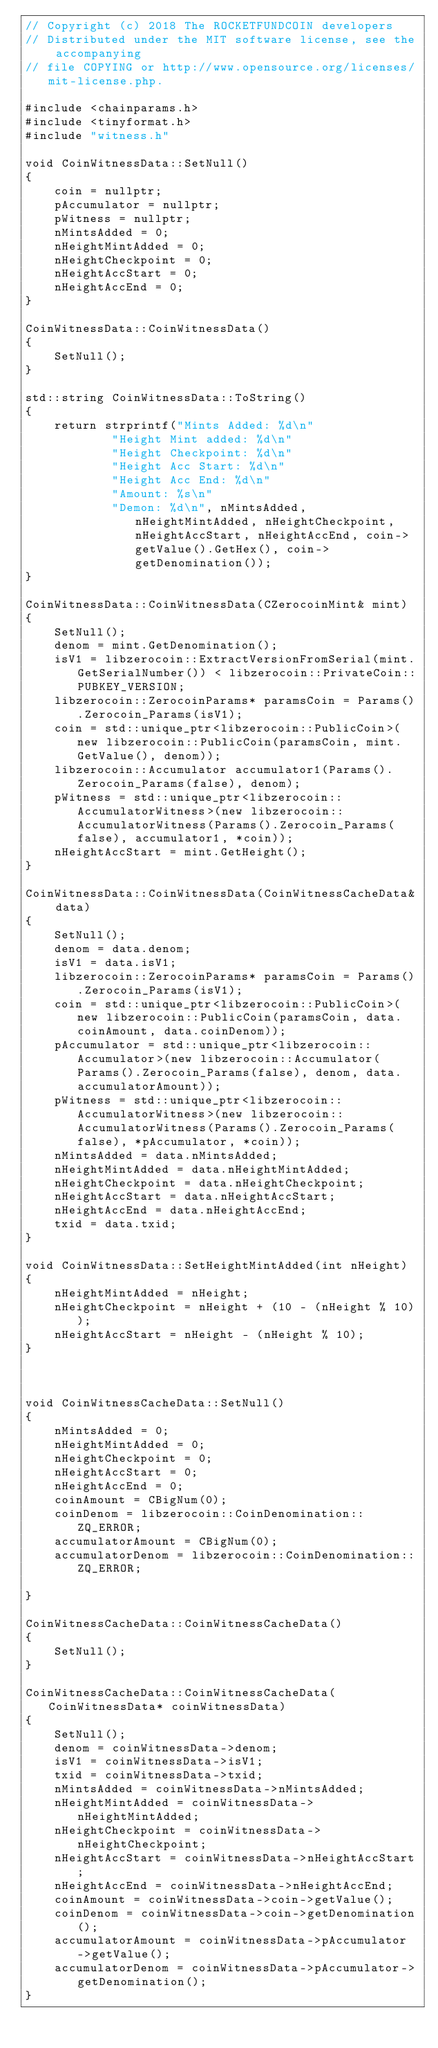<code> <loc_0><loc_0><loc_500><loc_500><_C++_>// Copyright (c) 2018 The ROCKETFUNDCOIN developers
// Distributed under the MIT software license, see the accompanying
// file COPYING or http://www.opensource.org/licenses/mit-license.php.

#include <chainparams.h>
#include <tinyformat.h>
#include "witness.h"

void CoinWitnessData::SetNull()
{
    coin = nullptr;
    pAccumulator = nullptr;
    pWitness = nullptr;
    nMintsAdded = 0;
    nHeightMintAdded = 0;
    nHeightCheckpoint = 0;
    nHeightAccStart = 0;
    nHeightAccEnd = 0;
}

CoinWitnessData::CoinWitnessData()
{
    SetNull();
}

std::string CoinWitnessData::ToString()
{
    return strprintf("Mints Added: %d\n"
            "Height Mint added: %d\n"
            "Height Checkpoint: %d\n"
            "Height Acc Start: %d\n"
            "Height Acc End: %d\n"
            "Amount: %s\n"
            "Demon: %d\n", nMintsAdded, nHeightMintAdded, nHeightCheckpoint, nHeightAccStart, nHeightAccEnd, coin->getValue().GetHex(), coin->getDenomination());
}

CoinWitnessData::CoinWitnessData(CZerocoinMint& mint)
{
    SetNull();
    denom = mint.GetDenomination();
    isV1 = libzerocoin::ExtractVersionFromSerial(mint.GetSerialNumber()) < libzerocoin::PrivateCoin::PUBKEY_VERSION;
    libzerocoin::ZerocoinParams* paramsCoin = Params().Zerocoin_Params(isV1);
    coin = std::unique_ptr<libzerocoin::PublicCoin>(new libzerocoin::PublicCoin(paramsCoin, mint.GetValue(), denom));
    libzerocoin::Accumulator accumulator1(Params().Zerocoin_Params(false), denom);
    pWitness = std::unique_ptr<libzerocoin::AccumulatorWitness>(new libzerocoin::AccumulatorWitness(Params().Zerocoin_Params(false), accumulator1, *coin));
    nHeightAccStart = mint.GetHeight();
}

CoinWitnessData::CoinWitnessData(CoinWitnessCacheData& data)
{
    SetNull();
    denom = data.denom;
    isV1 = data.isV1;
    libzerocoin::ZerocoinParams* paramsCoin = Params().Zerocoin_Params(isV1);
    coin = std::unique_ptr<libzerocoin::PublicCoin>(new libzerocoin::PublicCoin(paramsCoin, data.coinAmount, data.coinDenom));
    pAccumulator = std::unique_ptr<libzerocoin::Accumulator>(new libzerocoin::Accumulator(Params().Zerocoin_Params(false), denom, data.accumulatorAmount));
    pWitness = std::unique_ptr<libzerocoin::AccumulatorWitness>(new libzerocoin::AccumulatorWitness(Params().Zerocoin_Params(false), *pAccumulator, *coin));
    nMintsAdded = data.nMintsAdded;
    nHeightMintAdded = data.nHeightMintAdded;
    nHeightCheckpoint = data.nHeightCheckpoint;
    nHeightAccStart = data.nHeightAccStart;
    nHeightAccEnd = data.nHeightAccEnd;
    txid = data.txid;
}

void CoinWitnessData::SetHeightMintAdded(int nHeight)
{
    nHeightMintAdded = nHeight;
    nHeightCheckpoint = nHeight + (10 - (nHeight % 10));
    nHeightAccStart = nHeight - (nHeight % 10);
}



void CoinWitnessCacheData::SetNull()
{
    nMintsAdded = 0;
    nHeightMintAdded = 0;
    nHeightCheckpoint = 0;
    nHeightAccStart = 0;
    nHeightAccEnd = 0;
    coinAmount = CBigNum(0);
    coinDenom = libzerocoin::CoinDenomination::ZQ_ERROR;
    accumulatorAmount = CBigNum(0);
    accumulatorDenom = libzerocoin::CoinDenomination::ZQ_ERROR;

}

CoinWitnessCacheData::CoinWitnessCacheData()
{
    SetNull();
}

CoinWitnessCacheData::CoinWitnessCacheData(CoinWitnessData* coinWitnessData)
{
    SetNull();
    denom = coinWitnessData->denom;
    isV1 = coinWitnessData->isV1;
    txid = coinWitnessData->txid;
    nMintsAdded = coinWitnessData->nMintsAdded;
    nHeightMintAdded = coinWitnessData->nHeightMintAdded;
    nHeightCheckpoint = coinWitnessData->nHeightCheckpoint;
    nHeightAccStart = coinWitnessData->nHeightAccStart;
    nHeightAccEnd = coinWitnessData->nHeightAccEnd;
    coinAmount = coinWitnessData->coin->getValue();
    coinDenom = coinWitnessData->coin->getDenomination();
    accumulatorAmount = coinWitnessData->pAccumulator->getValue();
    accumulatorDenom = coinWitnessData->pAccumulator->getDenomination();
}

</code> 